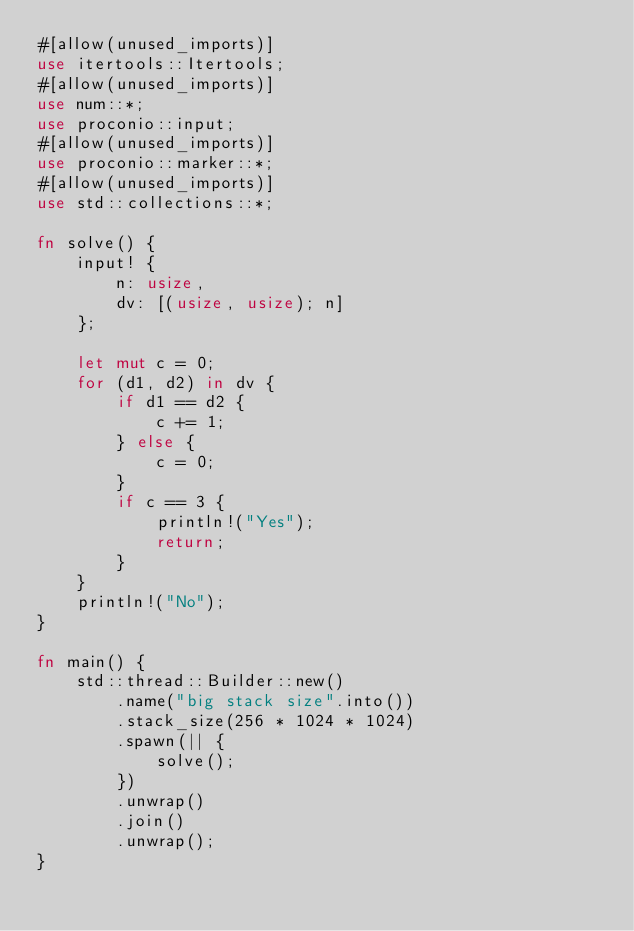Convert code to text. <code><loc_0><loc_0><loc_500><loc_500><_Rust_>#[allow(unused_imports)]
use itertools::Itertools;
#[allow(unused_imports)]
use num::*;
use proconio::input;
#[allow(unused_imports)]
use proconio::marker::*;
#[allow(unused_imports)]
use std::collections::*;

fn solve() {
    input! {
        n: usize,
        dv: [(usize, usize); n]
    };

    let mut c = 0;
    for (d1, d2) in dv {
        if d1 == d2 {
            c += 1;
        } else {
            c = 0;
        }
        if c == 3 {
            println!("Yes");
            return;
        }
    }
    println!("No");
}

fn main() {
    std::thread::Builder::new()
        .name("big stack size".into())
        .stack_size(256 * 1024 * 1024)
        .spawn(|| {
            solve();
        })
        .unwrap()
        .join()
        .unwrap();
}
</code> 